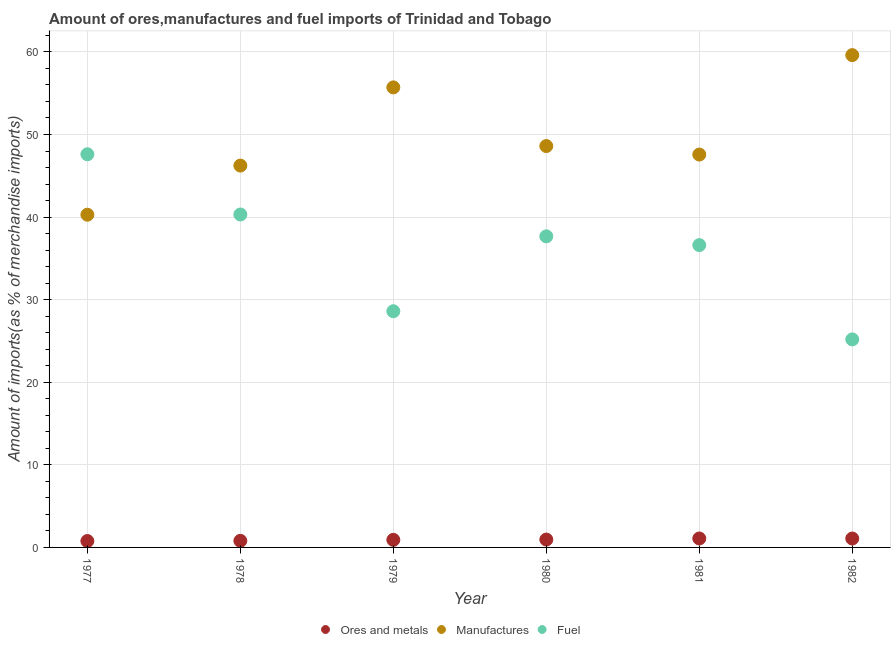What is the percentage of manufactures imports in 1981?
Provide a succinct answer. 47.57. Across all years, what is the maximum percentage of ores and metals imports?
Your answer should be compact. 1.08. Across all years, what is the minimum percentage of ores and metals imports?
Provide a short and direct response. 0.77. In which year was the percentage of manufactures imports maximum?
Your answer should be compact. 1982. What is the total percentage of ores and metals imports in the graph?
Your response must be concise. 5.61. What is the difference between the percentage of manufactures imports in 1978 and that in 1982?
Your answer should be compact. -13.38. What is the difference between the percentage of fuel imports in 1979 and the percentage of ores and metals imports in 1981?
Make the answer very short. 27.51. What is the average percentage of ores and metals imports per year?
Your response must be concise. 0.93. In the year 1980, what is the difference between the percentage of fuel imports and percentage of ores and metals imports?
Provide a short and direct response. 36.72. In how many years, is the percentage of manufactures imports greater than 38 %?
Keep it short and to the point. 6. What is the ratio of the percentage of manufactures imports in 1977 to that in 1980?
Your response must be concise. 0.83. What is the difference between the highest and the second highest percentage of fuel imports?
Provide a succinct answer. 7.3. What is the difference between the highest and the lowest percentage of manufactures imports?
Give a very brief answer. 19.32. Is it the case that in every year, the sum of the percentage of ores and metals imports and percentage of manufactures imports is greater than the percentage of fuel imports?
Provide a succinct answer. No. Does the percentage of ores and metals imports monotonically increase over the years?
Keep it short and to the point. No. Is the percentage of manufactures imports strictly greater than the percentage of ores and metals imports over the years?
Provide a succinct answer. Yes. How many dotlines are there?
Offer a terse response. 3. How many years are there in the graph?
Ensure brevity in your answer.  6. What is the difference between two consecutive major ticks on the Y-axis?
Your answer should be compact. 10. Are the values on the major ticks of Y-axis written in scientific E-notation?
Make the answer very short. No. Does the graph contain grids?
Provide a succinct answer. Yes. How many legend labels are there?
Offer a very short reply. 3. How are the legend labels stacked?
Make the answer very short. Horizontal. What is the title of the graph?
Make the answer very short. Amount of ores,manufactures and fuel imports of Trinidad and Tobago. Does "Taxes on income" appear as one of the legend labels in the graph?
Ensure brevity in your answer.  No. What is the label or title of the Y-axis?
Your response must be concise. Amount of imports(as % of merchandise imports). What is the Amount of imports(as % of merchandise imports) in Ores and metals in 1977?
Provide a short and direct response. 0.77. What is the Amount of imports(as % of merchandise imports) of Manufactures in 1977?
Make the answer very short. 40.29. What is the Amount of imports(as % of merchandise imports) in Fuel in 1977?
Your response must be concise. 47.61. What is the Amount of imports(as % of merchandise imports) of Ores and metals in 1978?
Provide a short and direct response. 0.8. What is the Amount of imports(as % of merchandise imports) of Manufactures in 1978?
Keep it short and to the point. 46.24. What is the Amount of imports(as % of merchandise imports) of Fuel in 1978?
Ensure brevity in your answer.  40.31. What is the Amount of imports(as % of merchandise imports) in Ores and metals in 1979?
Provide a short and direct response. 0.92. What is the Amount of imports(as % of merchandise imports) in Manufactures in 1979?
Offer a terse response. 55.71. What is the Amount of imports(as % of merchandise imports) of Fuel in 1979?
Offer a terse response. 28.6. What is the Amount of imports(as % of merchandise imports) of Ores and metals in 1980?
Make the answer very short. 0.95. What is the Amount of imports(as % of merchandise imports) of Manufactures in 1980?
Your answer should be very brief. 48.6. What is the Amount of imports(as % of merchandise imports) of Fuel in 1980?
Your answer should be compact. 37.67. What is the Amount of imports(as % of merchandise imports) in Ores and metals in 1981?
Your answer should be very brief. 1.08. What is the Amount of imports(as % of merchandise imports) of Manufactures in 1981?
Keep it short and to the point. 47.57. What is the Amount of imports(as % of merchandise imports) of Fuel in 1981?
Your response must be concise. 36.61. What is the Amount of imports(as % of merchandise imports) of Ores and metals in 1982?
Offer a terse response. 1.08. What is the Amount of imports(as % of merchandise imports) in Manufactures in 1982?
Your answer should be very brief. 59.61. What is the Amount of imports(as % of merchandise imports) in Fuel in 1982?
Your answer should be compact. 25.19. Across all years, what is the maximum Amount of imports(as % of merchandise imports) in Ores and metals?
Your answer should be very brief. 1.08. Across all years, what is the maximum Amount of imports(as % of merchandise imports) in Manufactures?
Make the answer very short. 59.61. Across all years, what is the maximum Amount of imports(as % of merchandise imports) in Fuel?
Keep it short and to the point. 47.61. Across all years, what is the minimum Amount of imports(as % of merchandise imports) in Ores and metals?
Offer a very short reply. 0.77. Across all years, what is the minimum Amount of imports(as % of merchandise imports) of Manufactures?
Offer a terse response. 40.29. Across all years, what is the minimum Amount of imports(as % of merchandise imports) in Fuel?
Ensure brevity in your answer.  25.19. What is the total Amount of imports(as % of merchandise imports) of Ores and metals in the graph?
Provide a succinct answer. 5.61. What is the total Amount of imports(as % of merchandise imports) in Manufactures in the graph?
Your answer should be compact. 298.01. What is the total Amount of imports(as % of merchandise imports) of Fuel in the graph?
Your answer should be very brief. 215.98. What is the difference between the Amount of imports(as % of merchandise imports) in Ores and metals in 1977 and that in 1978?
Your answer should be compact. -0.03. What is the difference between the Amount of imports(as % of merchandise imports) in Manufactures in 1977 and that in 1978?
Keep it short and to the point. -5.95. What is the difference between the Amount of imports(as % of merchandise imports) of Fuel in 1977 and that in 1978?
Give a very brief answer. 7.29. What is the difference between the Amount of imports(as % of merchandise imports) in Ores and metals in 1977 and that in 1979?
Your answer should be very brief. -0.15. What is the difference between the Amount of imports(as % of merchandise imports) in Manufactures in 1977 and that in 1979?
Your response must be concise. -15.42. What is the difference between the Amount of imports(as % of merchandise imports) in Fuel in 1977 and that in 1979?
Make the answer very short. 19.01. What is the difference between the Amount of imports(as % of merchandise imports) of Ores and metals in 1977 and that in 1980?
Your answer should be very brief. -0.18. What is the difference between the Amount of imports(as % of merchandise imports) in Manufactures in 1977 and that in 1980?
Provide a short and direct response. -8.31. What is the difference between the Amount of imports(as % of merchandise imports) in Fuel in 1977 and that in 1980?
Ensure brevity in your answer.  9.94. What is the difference between the Amount of imports(as % of merchandise imports) in Ores and metals in 1977 and that in 1981?
Your answer should be compact. -0.31. What is the difference between the Amount of imports(as % of merchandise imports) of Manufactures in 1977 and that in 1981?
Your answer should be very brief. -7.28. What is the difference between the Amount of imports(as % of merchandise imports) of Fuel in 1977 and that in 1981?
Provide a short and direct response. 11. What is the difference between the Amount of imports(as % of merchandise imports) of Ores and metals in 1977 and that in 1982?
Offer a terse response. -0.31. What is the difference between the Amount of imports(as % of merchandise imports) of Manufactures in 1977 and that in 1982?
Keep it short and to the point. -19.32. What is the difference between the Amount of imports(as % of merchandise imports) of Fuel in 1977 and that in 1982?
Ensure brevity in your answer.  22.42. What is the difference between the Amount of imports(as % of merchandise imports) of Ores and metals in 1978 and that in 1979?
Keep it short and to the point. -0.12. What is the difference between the Amount of imports(as % of merchandise imports) of Manufactures in 1978 and that in 1979?
Provide a succinct answer. -9.47. What is the difference between the Amount of imports(as % of merchandise imports) of Fuel in 1978 and that in 1979?
Your answer should be very brief. 11.71. What is the difference between the Amount of imports(as % of merchandise imports) in Ores and metals in 1978 and that in 1980?
Give a very brief answer. -0.15. What is the difference between the Amount of imports(as % of merchandise imports) of Manufactures in 1978 and that in 1980?
Offer a terse response. -2.36. What is the difference between the Amount of imports(as % of merchandise imports) of Fuel in 1978 and that in 1980?
Ensure brevity in your answer.  2.64. What is the difference between the Amount of imports(as % of merchandise imports) of Ores and metals in 1978 and that in 1981?
Provide a succinct answer. -0.29. What is the difference between the Amount of imports(as % of merchandise imports) in Manufactures in 1978 and that in 1981?
Your answer should be compact. -1.34. What is the difference between the Amount of imports(as % of merchandise imports) in Fuel in 1978 and that in 1981?
Provide a succinct answer. 3.71. What is the difference between the Amount of imports(as % of merchandise imports) in Ores and metals in 1978 and that in 1982?
Offer a very short reply. -0.28. What is the difference between the Amount of imports(as % of merchandise imports) in Manufactures in 1978 and that in 1982?
Your answer should be very brief. -13.38. What is the difference between the Amount of imports(as % of merchandise imports) of Fuel in 1978 and that in 1982?
Provide a short and direct response. 15.12. What is the difference between the Amount of imports(as % of merchandise imports) in Ores and metals in 1979 and that in 1980?
Your answer should be very brief. -0.03. What is the difference between the Amount of imports(as % of merchandise imports) in Manufactures in 1979 and that in 1980?
Provide a short and direct response. 7.11. What is the difference between the Amount of imports(as % of merchandise imports) of Fuel in 1979 and that in 1980?
Make the answer very short. -9.07. What is the difference between the Amount of imports(as % of merchandise imports) of Ores and metals in 1979 and that in 1981?
Your answer should be compact. -0.17. What is the difference between the Amount of imports(as % of merchandise imports) in Manufactures in 1979 and that in 1981?
Your response must be concise. 8.13. What is the difference between the Amount of imports(as % of merchandise imports) in Fuel in 1979 and that in 1981?
Your response must be concise. -8.01. What is the difference between the Amount of imports(as % of merchandise imports) in Ores and metals in 1979 and that in 1982?
Your answer should be compact. -0.16. What is the difference between the Amount of imports(as % of merchandise imports) in Manufactures in 1979 and that in 1982?
Ensure brevity in your answer.  -3.91. What is the difference between the Amount of imports(as % of merchandise imports) of Fuel in 1979 and that in 1982?
Your answer should be compact. 3.41. What is the difference between the Amount of imports(as % of merchandise imports) of Ores and metals in 1980 and that in 1981?
Offer a very short reply. -0.13. What is the difference between the Amount of imports(as % of merchandise imports) of Manufactures in 1980 and that in 1981?
Offer a terse response. 1.03. What is the difference between the Amount of imports(as % of merchandise imports) of Fuel in 1980 and that in 1981?
Your answer should be very brief. 1.06. What is the difference between the Amount of imports(as % of merchandise imports) in Ores and metals in 1980 and that in 1982?
Your answer should be very brief. -0.13. What is the difference between the Amount of imports(as % of merchandise imports) of Manufactures in 1980 and that in 1982?
Give a very brief answer. -11.01. What is the difference between the Amount of imports(as % of merchandise imports) of Fuel in 1980 and that in 1982?
Your answer should be compact. 12.48. What is the difference between the Amount of imports(as % of merchandise imports) in Ores and metals in 1981 and that in 1982?
Provide a succinct answer. 0.01. What is the difference between the Amount of imports(as % of merchandise imports) of Manufactures in 1981 and that in 1982?
Your response must be concise. -12.04. What is the difference between the Amount of imports(as % of merchandise imports) in Fuel in 1981 and that in 1982?
Offer a very short reply. 11.42. What is the difference between the Amount of imports(as % of merchandise imports) of Ores and metals in 1977 and the Amount of imports(as % of merchandise imports) of Manufactures in 1978?
Your answer should be very brief. -45.46. What is the difference between the Amount of imports(as % of merchandise imports) in Ores and metals in 1977 and the Amount of imports(as % of merchandise imports) in Fuel in 1978?
Your response must be concise. -39.54. What is the difference between the Amount of imports(as % of merchandise imports) of Manufactures in 1977 and the Amount of imports(as % of merchandise imports) of Fuel in 1978?
Ensure brevity in your answer.  -0.03. What is the difference between the Amount of imports(as % of merchandise imports) of Ores and metals in 1977 and the Amount of imports(as % of merchandise imports) of Manufactures in 1979?
Give a very brief answer. -54.93. What is the difference between the Amount of imports(as % of merchandise imports) in Ores and metals in 1977 and the Amount of imports(as % of merchandise imports) in Fuel in 1979?
Keep it short and to the point. -27.83. What is the difference between the Amount of imports(as % of merchandise imports) of Manufactures in 1977 and the Amount of imports(as % of merchandise imports) of Fuel in 1979?
Keep it short and to the point. 11.69. What is the difference between the Amount of imports(as % of merchandise imports) in Ores and metals in 1977 and the Amount of imports(as % of merchandise imports) in Manufactures in 1980?
Your answer should be compact. -47.83. What is the difference between the Amount of imports(as % of merchandise imports) in Ores and metals in 1977 and the Amount of imports(as % of merchandise imports) in Fuel in 1980?
Give a very brief answer. -36.9. What is the difference between the Amount of imports(as % of merchandise imports) in Manufactures in 1977 and the Amount of imports(as % of merchandise imports) in Fuel in 1980?
Make the answer very short. 2.62. What is the difference between the Amount of imports(as % of merchandise imports) of Ores and metals in 1977 and the Amount of imports(as % of merchandise imports) of Manufactures in 1981?
Your answer should be very brief. -46.8. What is the difference between the Amount of imports(as % of merchandise imports) of Ores and metals in 1977 and the Amount of imports(as % of merchandise imports) of Fuel in 1981?
Ensure brevity in your answer.  -35.83. What is the difference between the Amount of imports(as % of merchandise imports) of Manufactures in 1977 and the Amount of imports(as % of merchandise imports) of Fuel in 1981?
Offer a very short reply. 3.68. What is the difference between the Amount of imports(as % of merchandise imports) of Ores and metals in 1977 and the Amount of imports(as % of merchandise imports) of Manufactures in 1982?
Make the answer very short. -58.84. What is the difference between the Amount of imports(as % of merchandise imports) of Ores and metals in 1977 and the Amount of imports(as % of merchandise imports) of Fuel in 1982?
Provide a short and direct response. -24.42. What is the difference between the Amount of imports(as % of merchandise imports) of Manufactures in 1977 and the Amount of imports(as % of merchandise imports) of Fuel in 1982?
Offer a very short reply. 15.1. What is the difference between the Amount of imports(as % of merchandise imports) in Ores and metals in 1978 and the Amount of imports(as % of merchandise imports) in Manufactures in 1979?
Give a very brief answer. -54.91. What is the difference between the Amount of imports(as % of merchandise imports) in Ores and metals in 1978 and the Amount of imports(as % of merchandise imports) in Fuel in 1979?
Make the answer very short. -27.8. What is the difference between the Amount of imports(as % of merchandise imports) of Manufactures in 1978 and the Amount of imports(as % of merchandise imports) of Fuel in 1979?
Make the answer very short. 17.64. What is the difference between the Amount of imports(as % of merchandise imports) in Ores and metals in 1978 and the Amount of imports(as % of merchandise imports) in Manufactures in 1980?
Provide a short and direct response. -47.8. What is the difference between the Amount of imports(as % of merchandise imports) of Ores and metals in 1978 and the Amount of imports(as % of merchandise imports) of Fuel in 1980?
Your response must be concise. -36.87. What is the difference between the Amount of imports(as % of merchandise imports) in Manufactures in 1978 and the Amount of imports(as % of merchandise imports) in Fuel in 1980?
Provide a succinct answer. 8.57. What is the difference between the Amount of imports(as % of merchandise imports) of Ores and metals in 1978 and the Amount of imports(as % of merchandise imports) of Manufactures in 1981?
Offer a very short reply. -46.77. What is the difference between the Amount of imports(as % of merchandise imports) of Ores and metals in 1978 and the Amount of imports(as % of merchandise imports) of Fuel in 1981?
Ensure brevity in your answer.  -35.81. What is the difference between the Amount of imports(as % of merchandise imports) of Manufactures in 1978 and the Amount of imports(as % of merchandise imports) of Fuel in 1981?
Your answer should be compact. 9.63. What is the difference between the Amount of imports(as % of merchandise imports) of Ores and metals in 1978 and the Amount of imports(as % of merchandise imports) of Manufactures in 1982?
Ensure brevity in your answer.  -58.81. What is the difference between the Amount of imports(as % of merchandise imports) of Ores and metals in 1978 and the Amount of imports(as % of merchandise imports) of Fuel in 1982?
Provide a succinct answer. -24.39. What is the difference between the Amount of imports(as % of merchandise imports) in Manufactures in 1978 and the Amount of imports(as % of merchandise imports) in Fuel in 1982?
Your answer should be very brief. 21.05. What is the difference between the Amount of imports(as % of merchandise imports) of Ores and metals in 1979 and the Amount of imports(as % of merchandise imports) of Manufactures in 1980?
Make the answer very short. -47.68. What is the difference between the Amount of imports(as % of merchandise imports) of Ores and metals in 1979 and the Amount of imports(as % of merchandise imports) of Fuel in 1980?
Your response must be concise. -36.75. What is the difference between the Amount of imports(as % of merchandise imports) in Manufactures in 1979 and the Amount of imports(as % of merchandise imports) in Fuel in 1980?
Provide a succinct answer. 18.04. What is the difference between the Amount of imports(as % of merchandise imports) of Ores and metals in 1979 and the Amount of imports(as % of merchandise imports) of Manufactures in 1981?
Ensure brevity in your answer.  -46.65. What is the difference between the Amount of imports(as % of merchandise imports) of Ores and metals in 1979 and the Amount of imports(as % of merchandise imports) of Fuel in 1981?
Give a very brief answer. -35.69. What is the difference between the Amount of imports(as % of merchandise imports) in Manufactures in 1979 and the Amount of imports(as % of merchandise imports) in Fuel in 1981?
Ensure brevity in your answer.  19.1. What is the difference between the Amount of imports(as % of merchandise imports) of Ores and metals in 1979 and the Amount of imports(as % of merchandise imports) of Manufactures in 1982?
Keep it short and to the point. -58.69. What is the difference between the Amount of imports(as % of merchandise imports) of Ores and metals in 1979 and the Amount of imports(as % of merchandise imports) of Fuel in 1982?
Make the answer very short. -24.27. What is the difference between the Amount of imports(as % of merchandise imports) of Manufactures in 1979 and the Amount of imports(as % of merchandise imports) of Fuel in 1982?
Ensure brevity in your answer.  30.52. What is the difference between the Amount of imports(as % of merchandise imports) in Ores and metals in 1980 and the Amount of imports(as % of merchandise imports) in Manufactures in 1981?
Offer a terse response. -46.62. What is the difference between the Amount of imports(as % of merchandise imports) in Ores and metals in 1980 and the Amount of imports(as % of merchandise imports) in Fuel in 1981?
Offer a very short reply. -35.65. What is the difference between the Amount of imports(as % of merchandise imports) of Manufactures in 1980 and the Amount of imports(as % of merchandise imports) of Fuel in 1981?
Offer a terse response. 11.99. What is the difference between the Amount of imports(as % of merchandise imports) in Ores and metals in 1980 and the Amount of imports(as % of merchandise imports) in Manufactures in 1982?
Your response must be concise. -58.66. What is the difference between the Amount of imports(as % of merchandise imports) in Ores and metals in 1980 and the Amount of imports(as % of merchandise imports) in Fuel in 1982?
Provide a short and direct response. -24.24. What is the difference between the Amount of imports(as % of merchandise imports) of Manufactures in 1980 and the Amount of imports(as % of merchandise imports) of Fuel in 1982?
Keep it short and to the point. 23.41. What is the difference between the Amount of imports(as % of merchandise imports) of Ores and metals in 1981 and the Amount of imports(as % of merchandise imports) of Manufactures in 1982?
Keep it short and to the point. -58.53. What is the difference between the Amount of imports(as % of merchandise imports) of Ores and metals in 1981 and the Amount of imports(as % of merchandise imports) of Fuel in 1982?
Your answer should be compact. -24.11. What is the difference between the Amount of imports(as % of merchandise imports) of Manufactures in 1981 and the Amount of imports(as % of merchandise imports) of Fuel in 1982?
Your answer should be very brief. 22.38. What is the average Amount of imports(as % of merchandise imports) in Ores and metals per year?
Your answer should be very brief. 0.93. What is the average Amount of imports(as % of merchandise imports) in Manufactures per year?
Provide a succinct answer. 49.67. What is the average Amount of imports(as % of merchandise imports) of Fuel per year?
Ensure brevity in your answer.  36. In the year 1977, what is the difference between the Amount of imports(as % of merchandise imports) in Ores and metals and Amount of imports(as % of merchandise imports) in Manufactures?
Your answer should be compact. -39.51. In the year 1977, what is the difference between the Amount of imports(as % of merchandise imports) of Ores and metals and Amount of imports(as % of merchandise imports) of Fuel?
Give a very brief answer. -46.83. In the year 1977, what is the difference between the Amount of imports(as % of merchandise imports) of Manufactures and Amount of imports(as % of merchandise imports) of Fuel?
Ensure brevity in your answer.  -7.32. In the year 1978, what is the difference between the Amount of imports(as % of merchandise imports) in Ores and metals and Amount of imports(as % of merchandise imports) in Manufactures?
Make the answer very short. -45.44. In the year 1978, what is the difference between the Amount of imports(as % of merchandise imports) of Ores and metals and Amount of imports(as % of merchandise imports) of Fuel?
Your answer should be compact. -39.51. In the year 1978, what is the difference between the Amount of imports(as % of merchandise imports) in Manufactures and Amount of imports(as % of merchandise imports) in Fuel?
Your answer should be compact. 5.92. In the year 1979, what is the difference between the Amount of imports(as % of merchandise imports) in Ores and metals and Amount of imports(as % of merchandise imports) in Manufactures?
Offer a terse response. -54.79. In the year 1979, what is the difference between the Amount of imports(as % of merchandise imports) in Ores and metals and Amount of imports(as % of merchandise imports) in Fuel?
Offer a terse response. -27.68. In the year 1979, what is the difference between the Amount of imports(as % of merchandise imports) of Manufactures and Amount of imports(as % of merchandise imports) of Fuel?
Keep it short and to the point. 27.11. In the year 1980, what is the difference between the Amount of imports(as % of merchandise imports) of Ores and metals and Amount of imports(as % of merchandise imports) of Manufactures?
Your answer should be very brief. -47.65. In the year 1980, what is the difference between the Amount of imports(as % of merchandise imports) in Ores and metals and Amount of imports(as % of merchandise imports) in Fuel?
Your response must be concise. -36.72. In the year 1980, what is the difference between the Amount of imports(as % of merchandise imports) of Manufactures and Amount of imports(as % of merchandise imports) of Fuel?
Provide a short and direct response. 10.93. In the year 1981, what is the difference between the Amount of imports(as % of merchandise imports) of Ores and metals and Amount of imports(as % of merchandise imports) of Manufactures?
Provide a short and direct response. -46.49. In the year 1981, what is the difference between the Amount of imports(as % of merchandise imports) of Ores and metals and Amount of imports(as % of merchandise imports) of Fuel?
Offer a very short reply. -35.52. In the year 1981, what is the difference between the Amount of imports(as % of merchandise imports) in Manufactures and Amount of imports(as % of merchandise imports) in Fuel?
Provide a short and direct response. 10.96. In the year 1982, what is the difference between the Amount of imports(as % of merchandise imports) in Ores and metals and Amount of imports(as % of merchandise imports) in Manufactures?
Offer a very short reply. -58.53. In the year 1982, what is the difference between the Amount of imports(as % of merchandise imports) in Ores and metals and Amount of imports(as % of merchandise imports) in Fuel?
Provide a succinct answer. -24.11. In the year 1982, what is the difference between the Amount of imports(as % of merchandise imports) in Manufactures and Amount of imports(as % of merchandise imports) in Fuel?
Your answer should be very brief. 34.42. What is the ratio of the Amount of imports(as % of merchandise imports) in Ores and metals in 1977 to that in 1978?
Ensure brevity in your answer.  0.97. What is the ratio of the Amount of imports(as % of merchandise imports) in Manufactures in 1977 to that in 1978?
Ensure brevity in your answer.  0.87. What is the ratio of the Amount of imports(as % of merchandise imports) in Fuel in 1977 to that in 1978?
Ensure brevity in your answer.  1.18. What is the ratio of the Amount of imports(as % of merchandise imports) in Ores and metals in 1977 to that in 1979?
Give a very brief answer. 0.84. What is the ratio of the Amount of imports(as % of merchandise imports) of Manufactures in 1977 to that in 1979?
Offer a terse response. 0.72. What is the ratio of the Amount of imports(as % of merchandise imports) in Fuel in 1977 to that in 1979?
Make the answer very short. 1.66. What is the ratio of the Amount of imports(as % of merchandise imports) of Ores and metals in 1977 to that in 1980?
Your response must be concise. 0.81. What is the ratio of the Amount of imports(as % of merchandise imports) in Manufactures in 1977 to that in 1980?
Your answer should be very brief. 0.83. What is the ratio of the Amount of imports(as % of merchandise imports) of Fuel in 1977 to that in 1980?
Keep it short and to the point. 1.26. What is the ratio of the Amount of imports(as % of merchandise imports) in Ores and metals in 1977 to that in 1981?
Make the answer very short. 0.71. What is the ratio of the Amount of imports(as % of merchandise imports) in Manufactures in 1977 to that in 1981?
Offer a very short reply. 0.85. What is the ratio of the Amount of imports(as % of merchandise imports) in Fuel in 1977 to that in 1981?
Your answer should be compact. 1.3. What is the ratio of the Amount of imports(as % of merchandise imports) of Ores and metals in 1977 to that in 1982?
Keep it short and to the point. 0.72. What is the ratio of the Amount of imports(as % of merchandise imports) in Manufactures in 1977 to that in 1982?
Your answer should be compact. 0.68. What is the ratio of the Amount of imports(as % of merchandise imports) of Fuel in 1977 to that in 1982?
Ensure brevity in your answer.  1.89. What is the ratio of the Amount of imports(as % of merchandise imports) in Ores and metals in 1978 to that in 1979?
Give a very brief answer. 0.87. What is the ratio of the Amount of imports(as % of merchandise imports) of Manufactures in 1978 to that in 1979?
Make the answer very short. 0.83. What is the ratio of the Amount of imports(as % of merchandise imports) in Fuel in 1978 to that in 1979?
Provide a succinct answer. 1.41. What is the ratio of the Amount of imports(as % of merchandise imports) of Ores and metals in 1978 to that in 1980?
Ensure brevity in your answer.  0.84. What is the ratio of the Amount of imports(as % of merchandise imports) in Manufactures in 1978 to that in 1980?
Provide a succinct answer. 0.95. What is the ratio of the Amount of imports(as % of merchandise imports) in Fuel in 1978 to that in 1980?
Provide a succinct answer. 1.07. What is the ratio of the Amount of imports(as % of merchandise imports) of Ores and metals in 1978 to that in 1981?
Give a very brief answer. 0.74. What is the ratio of the Amount of imports(as % of merchandise imports) of Manufactures in 1978 to that in 1981?
Offer a terse response. 0.97. What is the ratio of the Amount of imports(as % of merchandise imports) of Fuel in 1978 to that in 1981?
Your response must be concise. 1.1. What is the ratio of the Amount of imports(as % of merchandise imports) in Ores and metals in 1978 to that in 1982?
Your response must be concise. 0.74. What is the ratio of the Amount of imports(as % of merchandise imports) of Manufactures in 1978 to that in 1982?
Offer a very short reply. 0.78. What is the ratio of the Amount of imports(as % of merchandise imports) in Fuel in 1978 to that in 1982?
Keep it short and to the point. 1.6. What is the ratio of the Amount of imports(as % of merchandise imports) in Ores and metals in 1979 to that in 1980?
Your answer should be compact. 0.96. What is the ratio of the Amount of imports(as % of merchandise imports) in Manufactures in 1979 to that in 1980?
Ensure brevity in your answer.  1.15. What is the ratio of the Amount of imports(as % of merchandise imports) of Fuel in 1979 to that in 1980?
Give a very brief answer. 0.76. What is the ratio of the Amount of imports(as % of merchandise imports) in Ores and metals in 1979 to that in 1981?
Your response must be concise. 0.85. What is the ratio of the Amount of imports(as % of merchandise imports) of Manufactures in 1979 to that in 1981?
Give a very brief answer. 1.17. What is the ratio of the Amount of imports(as % of merchandise imports) in Fuel in 1979 to that in 1981?
Provide a short and direct response. 0.78. What is the ratio of the Amount of imports(as % of merchandise imports) in Ores and metals in 1979 to that in 1982?
Provide a short and direct response. 0.85. What is the ratio of the Amount of imports(as % of merchandise imports) in Manufactures in 1979 to that in 1982?
Provide a short and direct response. 0.93. What is the ratio of the Amount of imports(as % of merchandise imports) of Fuel in 1979 to that in 1982?
Your answer should be very brief. 1.14. What is the ratio of the Amount of imports(as % of merchandise imports) in Ores and metals in 1980 to that in 1981?
Provide a succinct answer. 0.88. What is the ratio of the Amount of imports(as % of merchandise imports) in Manufactures in 1980 to that in 1981?
Your answer should be very brief. 1.02. What is the ratio of the Amount of imports(as % of merchandise imports) of Fuel in 1980 to that in 1981?
Provide a succinct answer. 1.03. What is the ratio of the Amount of imports(as % of merchandise imports) of Ores and metals in 1980 to that in 1982?
Provide a succinct answer. 0.88. What is the ratio of the Amount of imports(as % of merchandise imports) in Manufactures in 1980 to that in 1982?
Make the answer very short. 0.82. What is the ratio of the Amount of imports(as % of merchandise imports) in Fuel in 1980 to that in 1982?
Your response must be concise. 1.5. What is the ratio of the Amount of imports(as % of merchandise imports) of Ores and metals in 1981 to that in 1982?
Offer a very short reply. 1.01. What is the ratio of the Amount of imports(as % of merchandise imports) in Manufactures in 1981 to that in 1982?
Provide a short and direct response. 0.8. What is the ratio of the Amount of imports(as % of merchandise imports) of Fuel in 1981 to that in 1982?
Offer a very short reply. 1.45. What is the difference between the highest and the second highest Amount of imports(as % of merchandise imports) of Ores and metals?
Provide a short and direct response. 0.01. What is the difference between the highest and the second highest Amount of imports(as % of merchandise imports) in Manufactures?
Give a very brief answer. 3.91. What is the difference between the highest and the second highest Amount of imports(as % of merchandise imports) of Fuel?
Offer a very short reply. 7.29. What is the difference between the highest and the lowest Amount of imports(as % of merchandise imports) in Ores and metals?
Offer a terse response. 0.31. What is the difference between the highest and the lowest Amount of imports(as % of merchandise imports) in Manufactures?
Your response must be concise. 19.32. What is the difference between the highest and the lowest Amount of imports(as % of merchandise imports) of Fuel?
Your answer should be very brief. 22.42. 